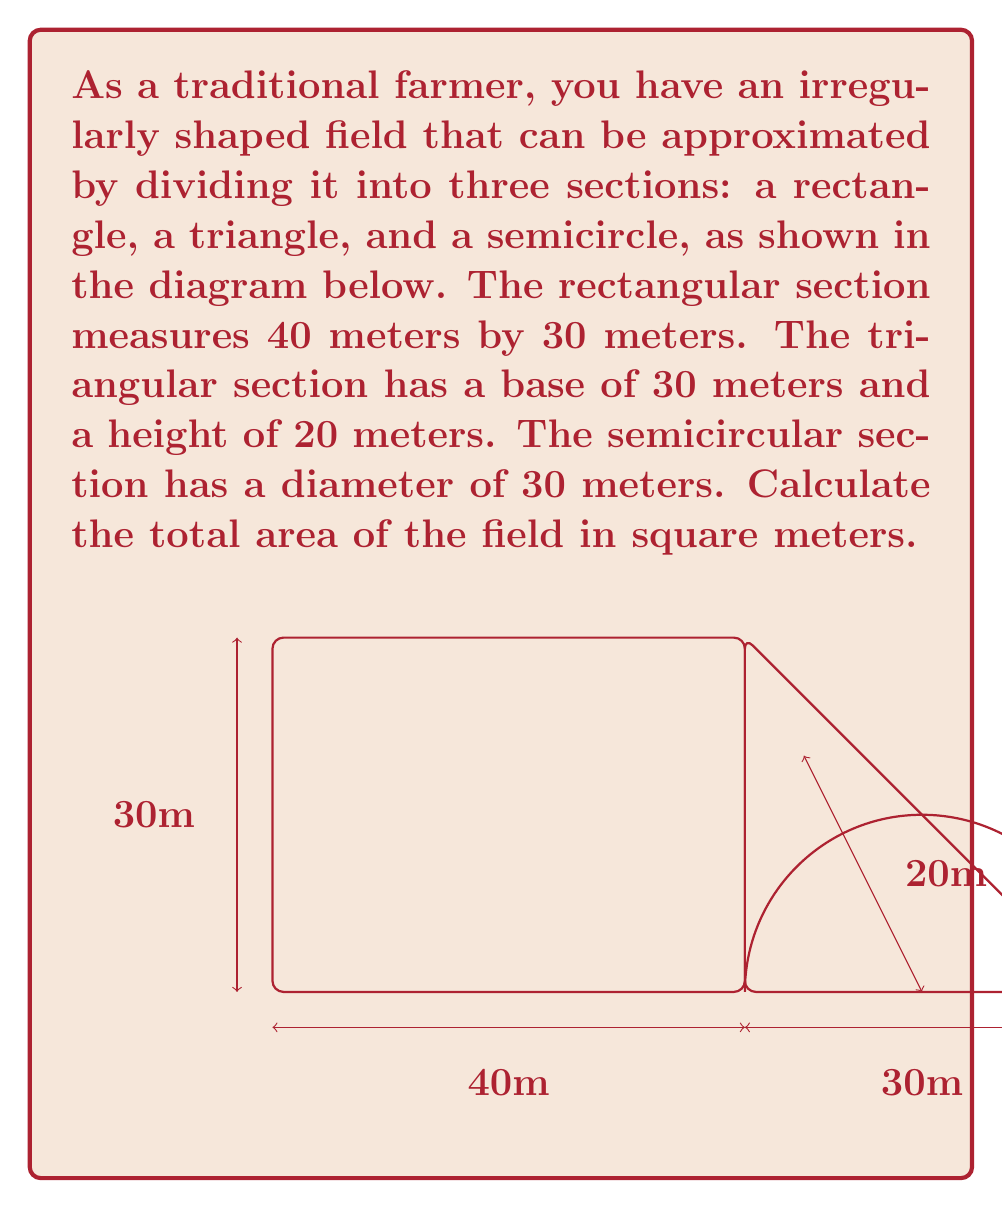Teach me how to tackle this problem. Let's calculate the area of each section separately and then sum them up:

1. Rectangle area:
   $A_r = l \times w = 40 \text{ m} \times 30 \text{ m} = 1200 \text{ m}^2$

2. Triangle area:
   $A_t = \frac{1}{2} \times b \times h = \frac{1}{2} \times 30 \text{ m} \times 20 \text{ m} = 300 \text{ m}^2$

3. Semicircle area:
   First, calculate the radius: $r = \frac{d}{2} = \frac{30 \text{ m}}{2} = 15 \text{ m}$
   Then, use the formula for a semicircle:
   $A_s = \frac{1}{2} \times \pi r^2 = \frac{1}{2} \times \pi \times (15 \text{ m})^2 = \frac{1}{2} \times \pi \times 225 \text{ m}^2 \approx 353.43 \text{ m}^2$

4. Total area:
   $A_{\text{total}} = A_r + A_t + A_s = 1200 \text{ m}^2 + 300 \text{ m}^2 + 353.43 \text{ m}^2 = 1853.43 \text{ m}^2$

Therefore, the total area of the irregularly shaped field is approximately 1853.43 square meters.
Answer: $1853.43 \text{ m}^2$ 